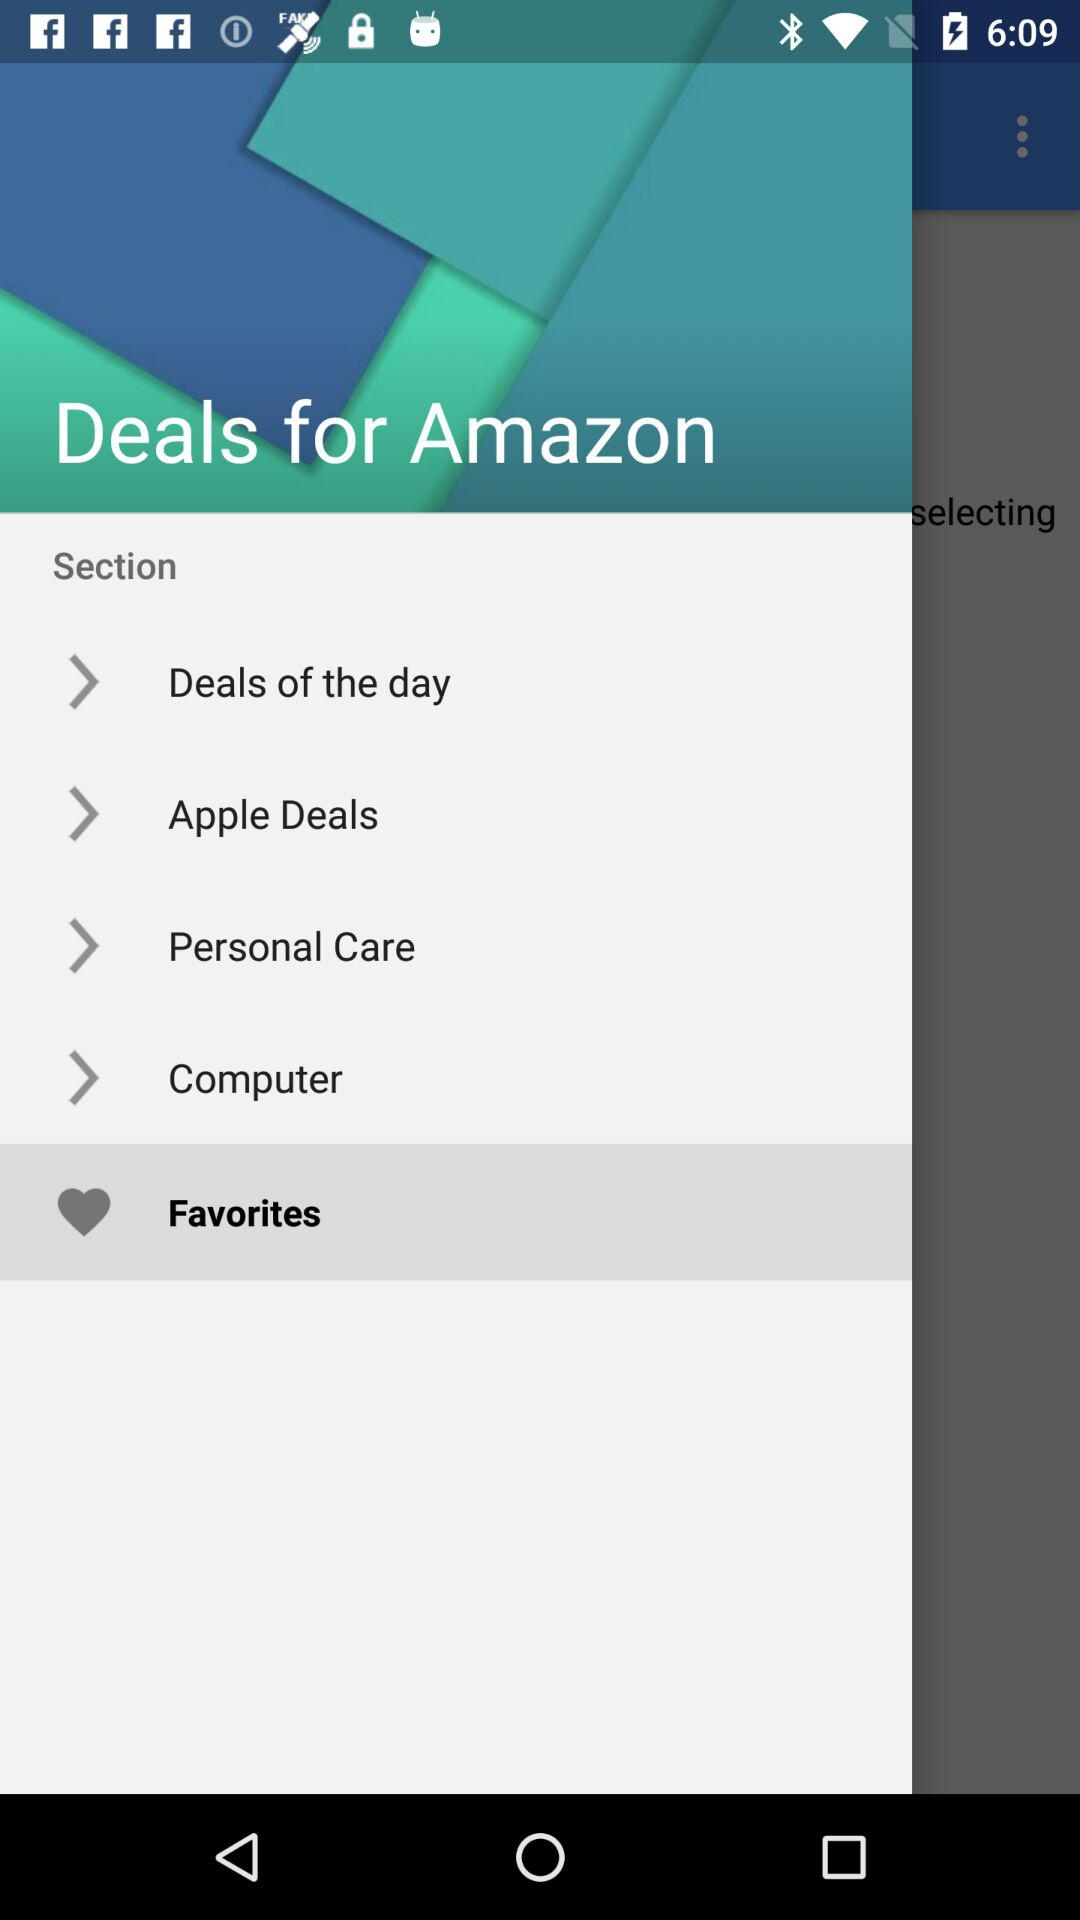Which item has been selected? The item that has been selected is "Favorites". 